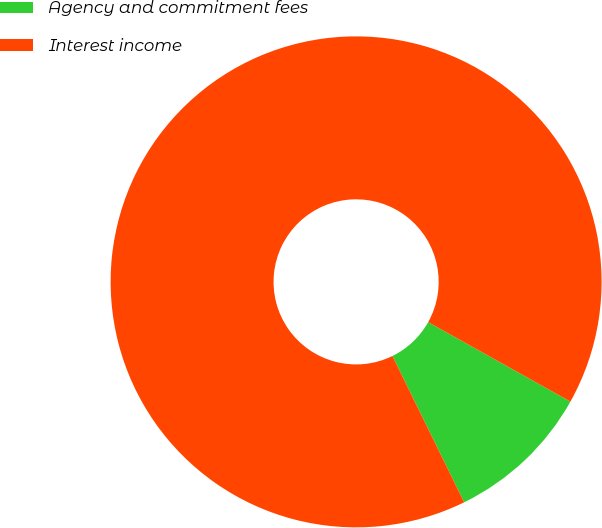Convert chart. <chart><loc_0><loc_0><loc_500><loc_500><pie_chart><fcel>Agency and commitment fees<fcel>Interest income<nl><fcel>9.64%<fcel>90.36%<nl></chart> 